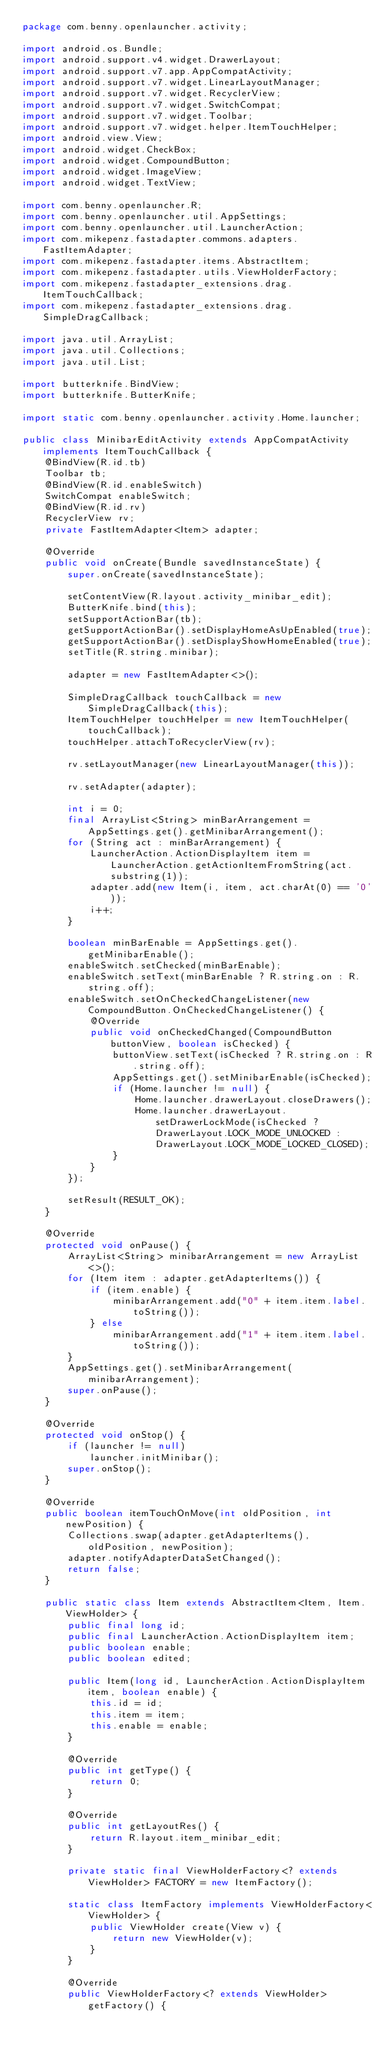<code> <loc_0><loc_0><loc_500><loc_500><_Java_>package com.benny.openlauncher.activity;

import android.os.Bundle;
import android.support.v4.widget.DrawerLayout;
import android.support.v7.app.AppCompatActivity;
import android.support.v7.widget.LinearLayoutManager;
import android.support.v7.widget.RecyclerView;
import android.support.v7.widget.SwitchCompat;
import android.support.v7.widget.Toolbar;
import android.support.v7.widget.helper.ItemTouchHelper;
import android.view.View;
import android.widget.CheckBox;
import android.widget.CompoundButton;
import android.widget.ImageView;
import android.widget.TextView;

import com.benny.openlauncher.R;
import com.benny.openlauncher.util.AppSettings;
import com.benny.openlauncher.util.LauncherAction;
import com.mikepenz.fastadapter.commons.adapters.FastItemAdapter;
import com.mikepenz.fastadapter.items.AbstractItem;
import com.mikepenz.fastadapter.utils.ViewHolderFactory;
import com.mikepenz.fastadapter_extensions.drag.ItemTouchCallback;
import com.mikepenz.fastadapter_extensions.drag.SimpleDragCallback;

import java.util.ArrayList;
import java.util.Collections;
import java.util.List;

import butterknife.BindView;
import butterknife.ButterKnife;

import static com.benny.openlauncher.activity.Home.launcher;

public class MinibarEditActivity extends AppCompatActivity implements ItemTouchCallback {
    @BindView(R.id.tb)
    Toolbar tb;
    @BindView(R.id.enableSwitch)
    SwitchCompat enableSwitch;
    @BindView(R.id.rv)
    RecyclerView rv;
    private FastItemAdapter<Item> adapter;

    @Override
    public void onCreate(Bundle savedInstanceState) {
        super.onCreate(savedInstanceState);

        setContentView(R.layout.activity_minibar_edit);
        ButterKnife.bind(this);
        setSupportActionBar(tb);
        getSupportActionBar().setDisplayHomeAsUpEnabled(true);
        getSupportActionBar().setDisplayShowHomeEnabled(true);
        setTitle(R.string.minibar);

        adapter = new FastItemAdapter<>();

        SimpleDragCallback touchCallback = new SimpleDragCallback(this);
        ItemTouchHelper touchHelper = new ItemTouchHelper(touchCallback);
        touchHelper.attachToRecyclerView(rv);

        rv.setLayoutManager(new LinearLayoutManager(this));

        rv.setAdapter(adapter);

        int i = 0;
        final ArrayList<String> minBarArrangement = AppSettings.get().getMinibarArrangement();
        for (String act : minBarArrangement) {
            LauncherAction.ActionDisplayItem item = LauncherAction.getActionItemFromString(act.substring(1));
            adapter.add(new Item(i, item, act.charAt(0) == '0'));
            i++;
        }

        boolean minBarEnable = AppSettings.get().getMinibarEnable();
        enableSwitch.setChecked(minBarEnable);
        enableSwitch.setText(minBarEnable ? R.string.on : R.string.off);
        enableSwitch.setOnCheckedChangeListener(new CompoundButton.OnCheckedChangeListener() {
            @Override
            public void onCheckedChanged(CompoundButton buttonView, boolean isChecked) {
                buttonView.setText(isChecked ? R.string.on : R.string.off);
                AppSettings.get().setMinibarEnable(isChecked);
                if (Home.launcher != null) {
                    Home.launcher.drawerLayout.closeDrawers();
                    Home.launcher.drawerLayout.setDrawerLockMode(isChecked ? DrawerLayout.LOCK_MODE_UNLOCKED : DrawerLayout.LOCK_MODE_LOCKED_CLOSED);
                }
            }
        });

        setResult(RESULT_OK);
    }

    @Override
    protected void onPause() {
        ArrayList<String> minibarArrangement = new ArrayList<>();
        for (Item item : adapter.getAdapterItems()) {
            if (item.enable) {
                minibarArrangement.add("0" + item.item.label.toString());
            } else
                minibarArrangement.add("1" + item.item.label.toString());
        }
        AppSettings.get().setMinibarArrangement(minibarArrangement);
        super.onPause();
    }

    @Override
    protected void onStop() {
        if (launcher != null)
            launcher.initMinibar();
        super.onStop();
    }

    @Override
    public boolean itemTouchOnMove(int oldPosition, int newPosition) {
        Collections.swap(adapter.getAdapterItems(), oldPosition, newPosition);
        adapter.notifyAdapterDataSetChanged();
        return false;
    }

    public static class Item extends AbstractItem<Item, Item.ViewHolder> {
        public final long id;
        public final LauncherAction.ActionDisplayItem item;
        public boolean enable;
        public boolean edited;

        public Item(long id, LauncherAction.ActionDisplayItem item, boolean enable) {
            this.id = id;
            this.item = item;
            this.enable = enable;
        }

        @Override
        public int getType() {
            return 0;
        }

        @Override
        public int getLayoutRes() {
            return R.layout.item_minibar_edit;
        }

        private static final ViewHolderFactory<? extends ViewHolder> FACTORY = new ItemFactory();

        static class ItemFactory implements ViewHolderFactory<ViewHolder> {
            public ViewHolder create(View v) {
                return new ViewHolder(v);
            }
        }

        @Override
        public ViewHolderFactory<? extends ViewHolder> getFactory() {</code> 